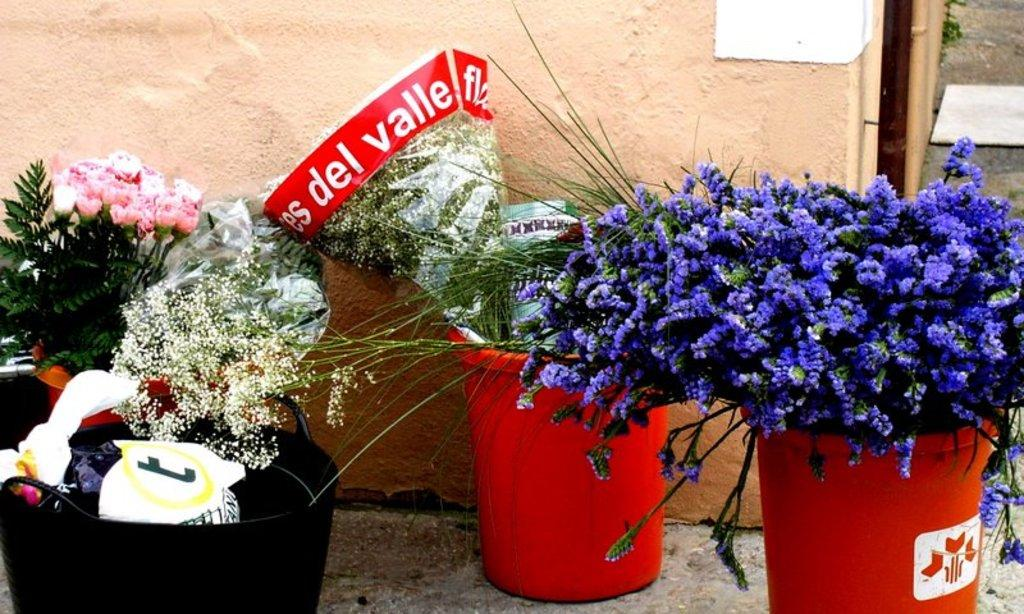What type of objects are present in the image related to flowers? There are flower pots and bouquets in the image. Where are the flower pots and bouquets located in the image? Both the flower pots and bouquets are present on the ground. Can you describe the arrangement of the flower pots and bouquets in the image? Unfortunately, the provided facts do not give enough information to describe the arrangement of the flower pots and bouquets. What type of circle can be seen in the image? There is no circle present in the image. Is there a gate visible in the image? There is no gate present in the image. 